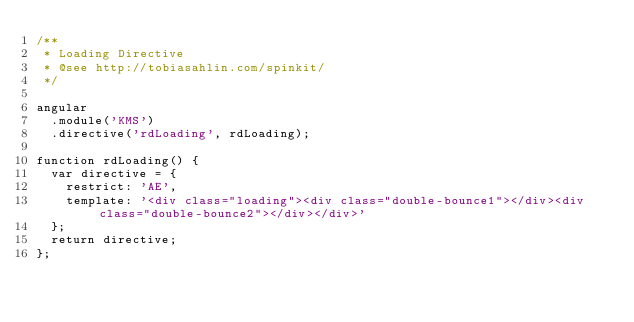Convert code to text. <code><loc_0><loc_0><loc_500><loc_500><_JavaScript_>/**
 * Loading Directive
 * @see http://tobiasahlin.com/spinkit/
 */

angular
	.module('KMS')
	.directive('rdLoading', rdLoading);

function rdLoading() {
	var directive = {
		restrict: 'AE',
		template: '<div class="loading"><div class="double-bounce1"></div><div class="double-bounce2"></div></div>'
	};
	return directive;
};</code> 